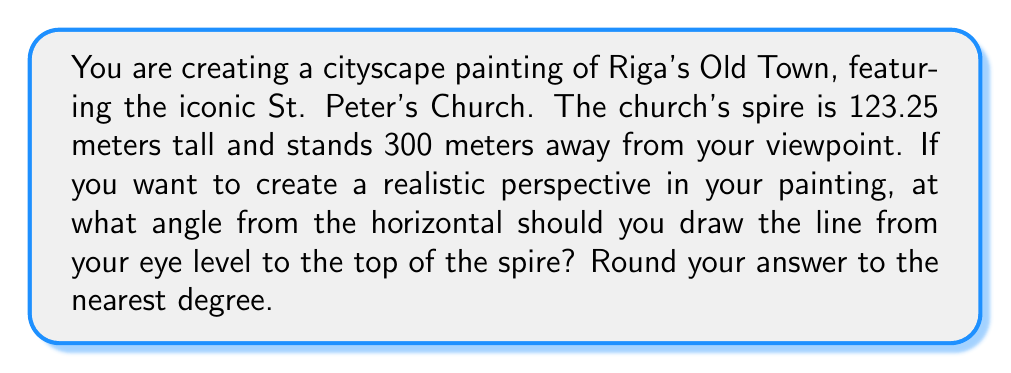Could you help me with this problem? To solve this problem, we need to use trigonometry. Let's break it down step-by-step:

1) First, we need to visualize the scenario. We have a right triangle where:
   - The base is the distance from your viewpoint to the church (300 meters)
   - The height is the height of the church spire (123.25 meters)
   - The hypotenuse is the line of sight from your eye level to the top of the spire

2) We need to find the angle this line of sight makes with the horizontal. This is the angle opposite to the height in our right triangle.

3) We can use the arctangent function to find this angle. The tangent of an angle in a right triangle is the opposite side divided by the adjacent side.

4) In this case:
   $$ \tan(\theta) = \frac{\text{opposite}}{\text{adjacent}} = \frac{123.25}{300} $$

5) To find the angle, we take the arctangent (or inverse tangent) of this ratio:
   $$ \theta = \arctan(\frac{123.25}{300}) $$

6) Using a calculator or computer:
   $$ \theta \approx 22.3326^\circ $$

7) Rounding to the nearest degree as requested:
   $$ \theta \approx 22^\circ $$

This angle will help create a realistic perspective in your cityscape painting of Riga's Old Town.
Answer: $22^\circ$ 